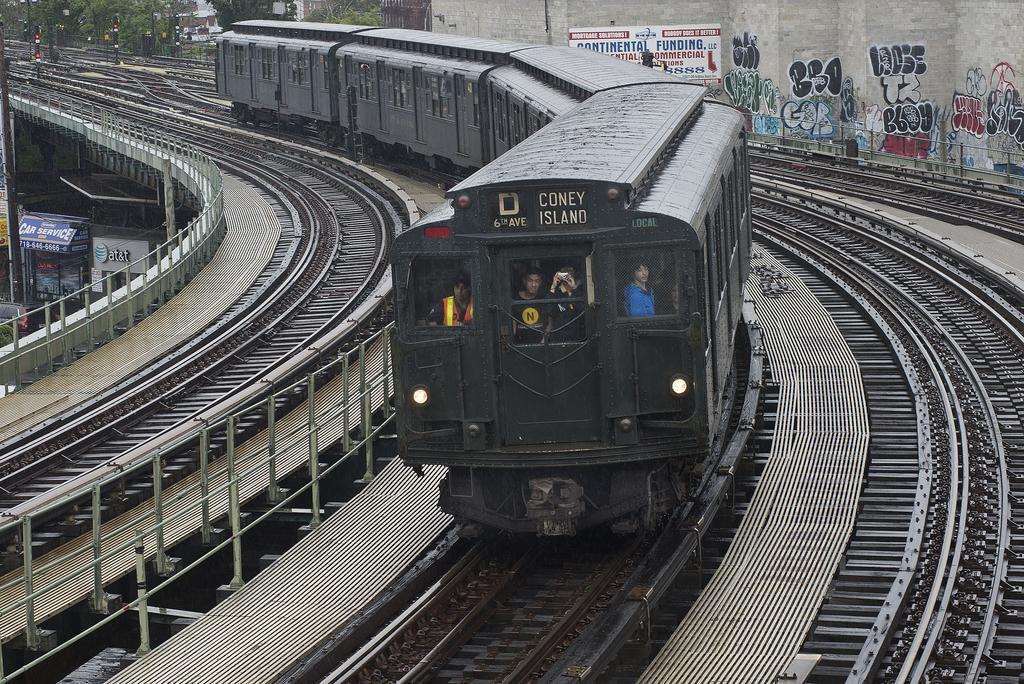<image>
Give a short and clear explanation of the subsequent image. A train that says D Coney Island on the top of it. 